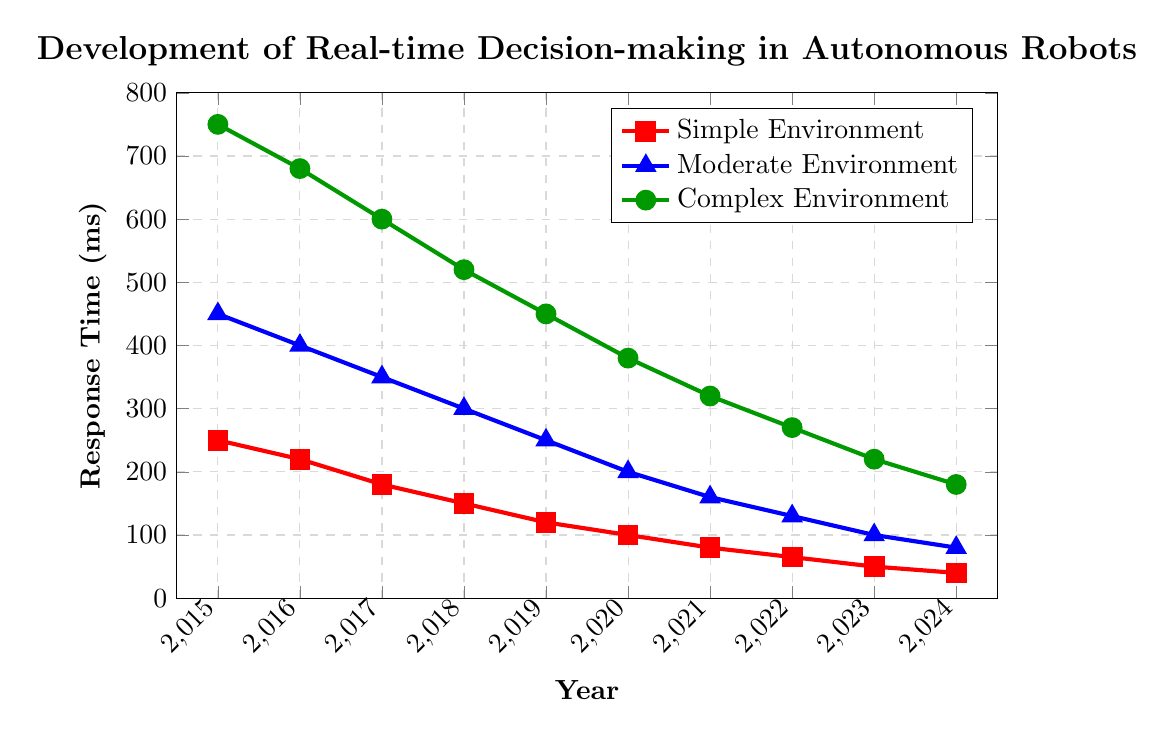What is the response time in a simple environment in 2021? Look at the red line corresponding to the "Simple Environment" and find the data point for the year 2021. The y-axis value at this point gives the response time.
Answer: 80 ms In which year did the response time in complex environments drop below 500 ms? Track the green line corresponding to the "Complex Environment" and see when it first falls below the 500 ms mark. This happens between 2018 and 2019, so the exact year is 2018.
Answer: 2018 By how much did the response time in a moderate environment improve from 2015 to 2024? Identify the response times for the "Moderate Environment" (blue line) for the years 2015 and 2024. In 2015, it was 450 ms, and in 2024, it is 80 ms. The change is calculated as 450 - 80.
Answer: 370 ms Which environment saw the greatest improvement in response time from 2015 to 2024? Determine the response times for all three environments in 2015 and 2024, then calculate the improvement for each. 
    Simple: 250 - 40 = 210
    Moderate: 450 - 80 = 370
    Complex: 750 - 180 = 570
The greatest improvement is in the complex environment.
Answer: Complex Environment What is the approximate average response time in a simple environment over the 10 years? Add the response times for the "Simple Environment" (250, 220, 180, 150, 120, 100, 80, 65, 50, 40) and divide by the number of years (10). The sum is 1255, so the average is 1255 / 10.
Answer: 125.5 ms How does the response time trend for moderate environments compare to complex environments over the years? Observe the slopes of the blue and green lines. Both lines show a decreasing trend, but the green line (complex environment) has a steeper slope than the blue line (moderate environment), showing a faster improvement rate.
Answer: Complex environment shows a faster improvement rate In which year do all three environments have their respective closest response times? Identify a year where the response times are closest together for all three environments. In 2024, response times are 40 ms (simple), 80 ms (moderate), and 180 ms (complex), which are the closest over all years.
Answer: 2024 What visual attribute differentiates the response times in complex environments? Notice that the complex environments are represented with a solid green line with circular marks, differentiating from the red squares and blue triangles used for other environments.
Answer: Green line, circular marks Compare the percent improvement in response time from 2015 to 2024 in simple versus moderate environments. Calculate the percent improvement for both environments.
    Simple: ((250 - 40) / 250) * 100 = 84%
    Moderate: ((450 - 80) / 450) * 100 = 82.22%
The simple environment shows a slightly higher percent improvement.
Answer: Simple: 84%, Moderate: 82.22% 